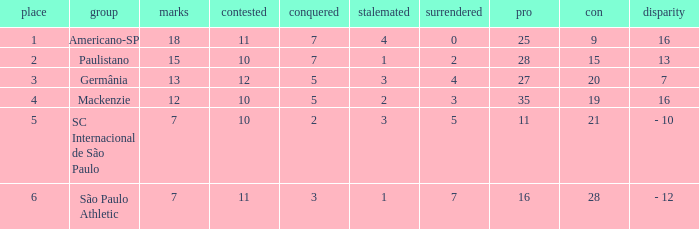Name the most for when difference is 7 27.0. 